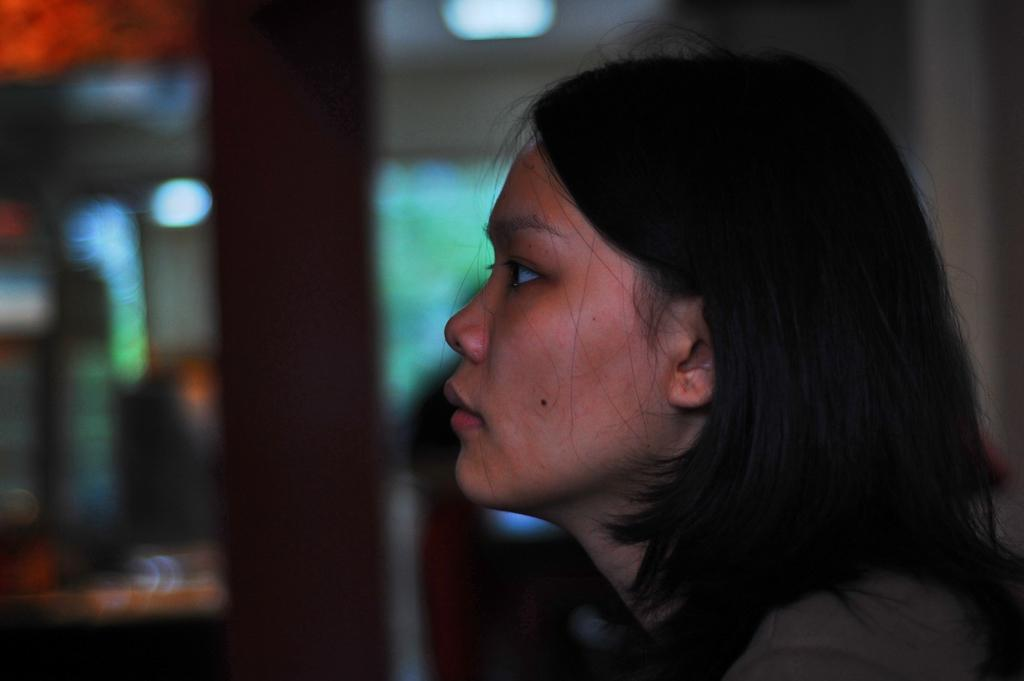Who is the main subject in the image? There is a woman in the image. Can you describe the background of the image? The background of the image is blurred. Is the woman in danger of being crushed by a parcel in the image? There is no parcel present in the image, so it is not possible to determine if the woman is in danger of being crushed. 